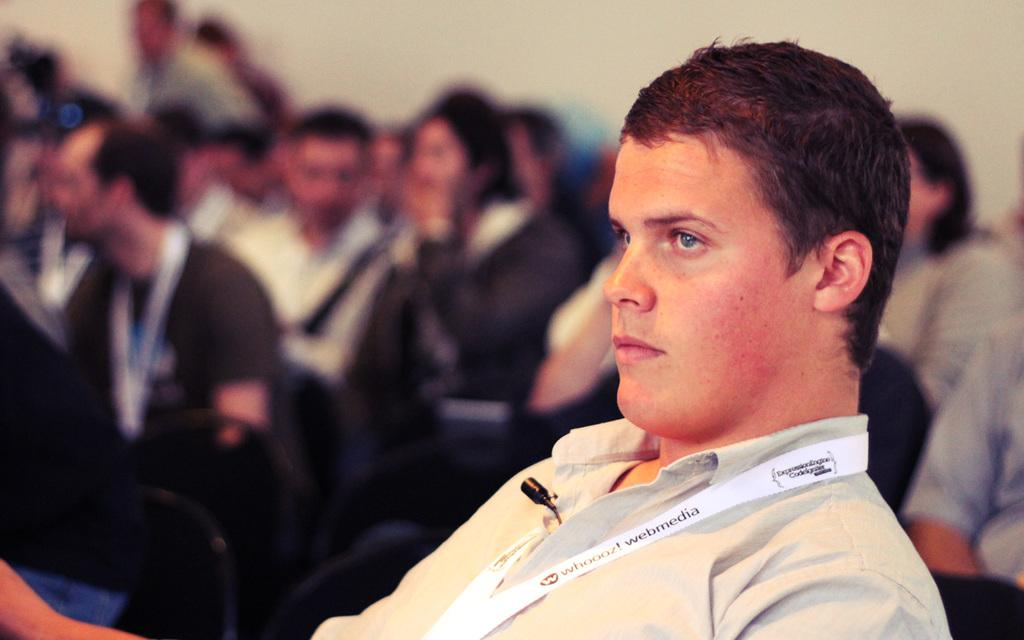What are the people in the image doing? The people in the image are sitting on chairs. What can be seen in the background of the image? There is a wall in the background of the image. What type of polish is being applied to the chairs in the image? There is no indication in the image that any polish is being applied to the chairs. 